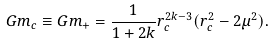<formula> <loc_0><loc_0><loc_500><loc_500>G m _ { c } \equiv G m _ { + } = \frac { 1 } { 1 + 2 k } r _ { c } ^ { 2 k - 3 } ( r _ { c } ^ { 2 } - 2 \mu ^ { 2 } ) .</formula> 